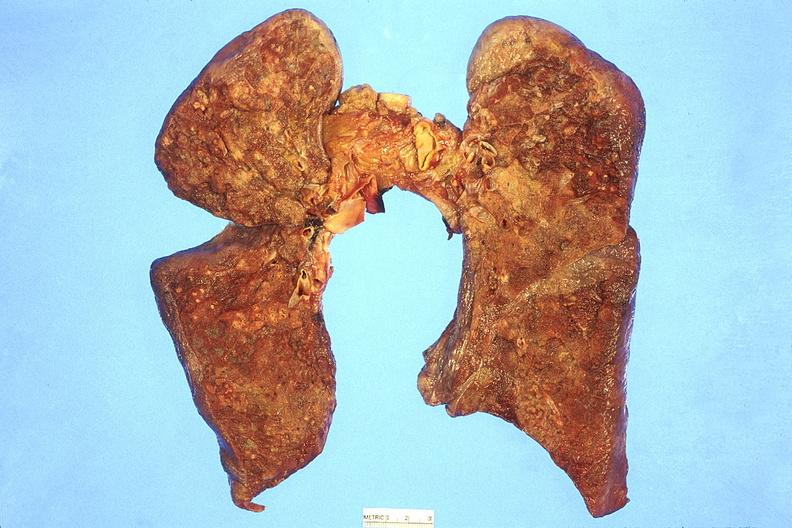s chronic myelogenous leukemia in blast crisis present?
Answer the question using a single word or phrase. No 